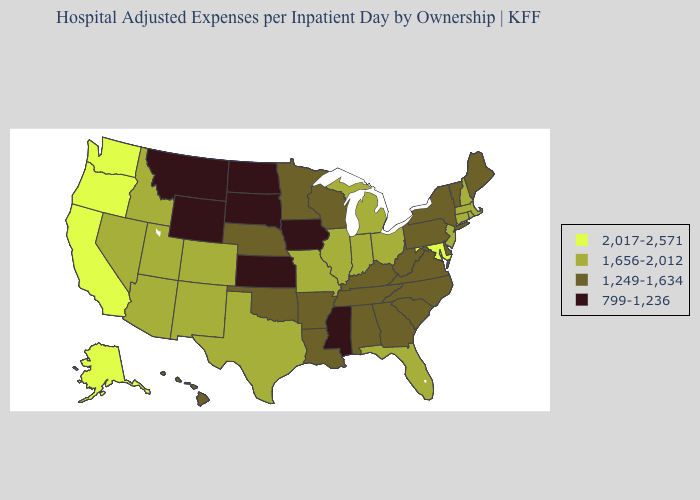Among the states that border Nebraska , which have the highest value?
Short answer required. Colorado, Missouri. Among the states that border Indiana , does Michigan have the lowest value?
Be succinct. No. What is the value of California?
Keep it brief. 2,017-2,571. Name the states that have a value in the range 1,656-2,012?
Concise answer only. Arizona, Colorado, Connecticut, Florida, Idaho, Illinois, Indiana, Massachusetts, Michigan, Missouri, Nevada, New Hampshire, New Jersey, New Mexico, Ohio, Rhode Island, Texas, Utah. Does Pennsylvania have the highest value in the Northeast?
Give a very brief answer. No. Among the states that border Michigan , does Wisconsin have the highest value?
Give a very brief answer. No. Name the states that have a value in the range 1,656-2,012?
Answer briefly. Arizona, Colorado, Connecticut, Florida, Idaho, Illinois, Indiana, Massachusetts, Michigan, Missouri, Nevada, New Hampshire, New Jersey, New Mexico, Ohio, Rhode Island, Texas, Utah. Name the states that have a value in the range 799-1,236?
Concise answer only. Iowa, Kansas, Mississippi, Montana, North Dakota, South Dakota, Wyoming. Name the states that have a value in the range 2,017-2,571?
Give a very brief answer. Alaska, California, Maryland, Oregon, Washington. What is the lowest value in the West?
Answer briefly. 799-1,236. Is the legend a continuous bar?
Keep it brief. No. Does Arizona have the lowest value in the West?
Give a very brief answer. No. What is the value of Michigan?
Quick response, please. 1,656-2,012. Name the states that have a value in the range 1,656-2,012?
Be succinct. Arizona, Colorado, Connecticut, Florida, Idaho, Illinois, Indiana, Massachusetts, Michigan, Missouri, Nevada, New Hampshire, New Jersey, New Mexico, Ohio, Rhode Island, Texas, Utah. What is the value of Wisconsin?
Short answer required. 1,249-1,634. 